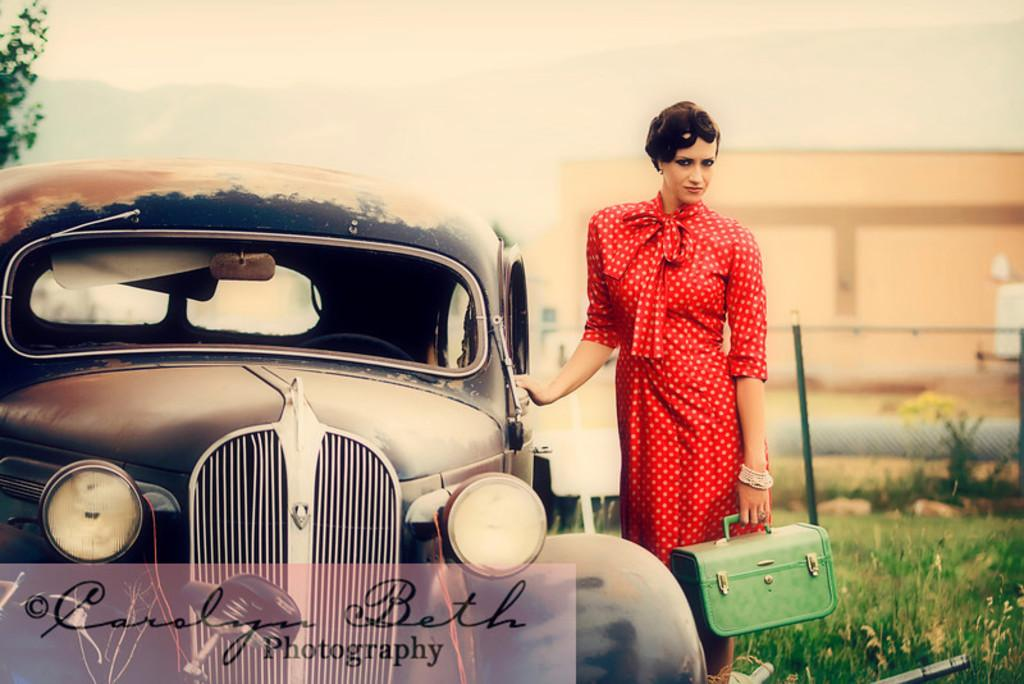Who is present in the image? There is a woman in the image. What is the woman holding or carrying? The woman is carrying a bag. Where is the woman located in relation to the car? The woman is standing near a car. What can be seen in the background of the image? There are plants visible in the background of the image. What type of twig is the woman using to measure the pollution in the image? There is no twig or mention of pollution in the image; it simply features a woman standing near a car with plants in the background. 